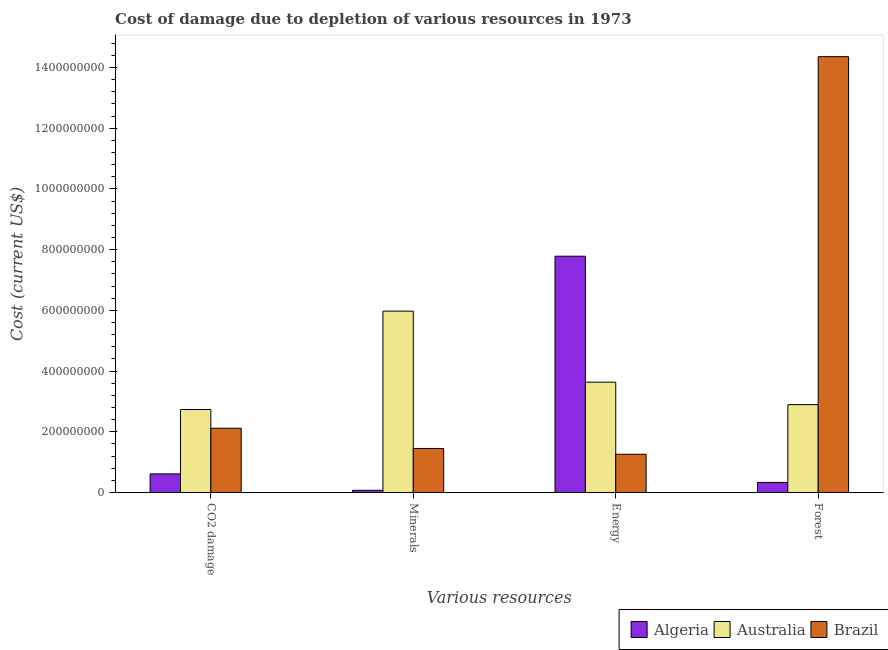Are the number of bars per tick equal to the number of legend labels?
Make the answer very short. Yes. How many bars are there on the 1st tick from the left?
Keep it short and to the point. 3. How many bars are there on the 4th tick from the right?
Make the answer very short. 3. What is the label of the 2nd group of bars from the left?
Your answer should be very brief. Minerals. What is the cost of damage due to depletion of forests in Algeria?
Offer a terse response. 3.31e+07. Across all countries, what is the maximum cost of damage due to depletion of coal?
Your response must be concise. 2.73e+08. Across all countries, what is the minimum cost of damage due to depletion of energy?
Offer a very short reply. 1.26e+08. In which country was the cost of damage due to depletion of coal maximum?
Your response must be concise. Australia. In which country was the cost of damage due to depletion of coal minimum?
Ensure brevity in your answer.  Algeria. What is the total cost of damage due to depletion of minerals in the graph?
Your response must be concise. 7.49e+08. What is the difference between the cost of damage due to depletion of minerals in Australia and that in Algeria?
Offer a very short reply. 5.90e+08. What is the difference between the cost of damage due to depletion of energy in Australia and the cost of damage due to depletion of minerals in Brazil?
Give a very brief answer. 2.18e+08. What is the average cost of damage due to depletion of forests per country?
Offer a terse response. 5.86e+08. What is the difference between the cost of damage due to depletion of coal and cost of damage due to depletion of minerals in Algeria?
Ensure brevity in your answer.  5.41e+07. In how many countries, is the cost of damage due to depletion of forests greater than 120000000 US$?
Offer a very short reply. 2. What is the ratio of the cost of damage due to depletion of energy in Algeria to that in Brazil?
Keep it short and to the point. 6.18. Is the cost of damage due to depletion of minerals in Australia less than that in Algeria?
Ensure brevity in your answer.  No. Is the difference between the cost of damage due to depletion of forests in Australia and Brazil greater than the difference between the cost of damage due to depletion of coal in Australia and Brazil?
Provide a succinct answer. No. What is the difference between the highest and the second highest cost of damage due to depletion of energy?
Your answer should be compact. 4.15e+08. What is the difference between the highest and the lowest cost of damage due to depletion of energy?
Your answer should be compact. 6.52e+08. In how many countries, is the cost of damage due to depletion of forests greater than the average cost of damage due to depletion of forests taken over all countries?
Offer a very short reply. 1. Is it the case that in every country, the sum of the cost of damage due to depletion of coal and cost of damage due to depletion of forests is greater than the sum of cost of damage due to depletion of energy and cost of damage due to depletion of minerals?
Your answer should be compact. No. What does the 3rd bar from the left in CO2 damage represents?
Offer a very short reply. Brazil. Is it the case that in every country, the sum of the cost of damage due to depletion of coal and cost of damage due to depletion of minerals is greater than the cost of damage due to depletion of energy?
Make the answer very short. No. How many bars are there?
Ensure brevity in your answer.  12. Are all the bars in the graph horizontal?
Provide a short and direct response. No. How many countries are there in the graph?
Provide a succinct answer. 3. Does the graph contain grids?
Offer a terse response. No. How many legend labels are there?
Give a very brief answer. 3. How are the legend labels stacked?
Ensure brevity in your answer.  Horizontal. What is the title of the graph?
Your response must be concise. Cost of damage due to depletion of various resources in 1973 . What is the label or title of the X-axis?
Your answer should be very brief. Various resources. What is the label or title of the Y-axis?
Keep it short and to the point. Cost (current US$). What is the Cost (current US$) in Algeria in CO2 damage?
Provide a succinct answer. 6.12e+07. What is the Cost (current US$) in Australia in CO2 damage?
Your answer should be compact. 2.73e+08. What is the Cost (current US$) in Brazil in CO2 damage?
Offer a very short reply. 2.12e+08. What is the Cost (current US$) in Algeria in Minerals?
Your response must be concise. 7.17e+06. What is the Cost (current US$) of Australia in Minerals?
Ensure brevity in your answer.  5.97e+08. What is the Cost (current US$) of Brazil in Minerals?
Your response must be concise. 1.45e+08. What is the Cost (current US$) in Algeria in Energy?
Keep it short and to the point. 7.78e+08. What is the Cost (current US$) in Australia in Energy?
Ensure brevity in your answer.  3.63e+08. What is the Cost (current US$) in Brazil in Energy?
Your response must be concise. 1.26e+08. What is the Cost (current US$) in Algeria in Forest?
Give a very brief answer. 3.31e+07. What is the Cost (current US$) in Australia in Forest?
Give a very brief answer. 2.89e+08. What is the Cost (current US$) in Brazil in Forest?
Your response must be concise. 1.44e+09. Across all Various resources, what is the maximum Cost (current US$) in Algeria?
Offer a terse response. 7.78e+08. Across all Various resources, what is the maximum Cost (current US$) of Australia?
Your answer should be very brief. 5.97e+08. Across all Various resources, what is the maximum Cost (current US$) of Brazil?
Give a very brief answer. 1.44e+09. Across all Various resources, what is the minimum Cost (current US$) in Algeria?
Provide a succinct answer. 7.17e+06. Across all Various resources, what is the minimum Cost (current US$) in Australia?
Offer a terse response. 2.73e+08. Across all Various resources, what is the minimum Cost (current US$) in Brazil?
Offer a terse response. 1.26e+08. What is the total Cost (current US$) of Algeria in the graph?
Make the answer very short. 8.80e+08. What is the total Cost (current US$) in Australia in the graph?
Give a very brief answer. 1.52e+09. What is the total Cost (current US$) of Brazil in the graph?
Your response must be concise. 1.92e+09. What is the difference between the Cost (current US$) of Algeria in CO2 damage and that in Minerals?
Offer a terse response. 5.41e+07. What is the difference between the Cost (current US$) in Australia in CO2 damage and that in Minerals?
Give a very brief answer. -3.24e+08. What is the difference between the Cost (current US$) of Brazil in CO2 damage and that in Minerals?
Provide a short and direct response. 6.67e+07. What is the difference between the Cost (current US$) in Algeria in CO2 damage and that in Energy?
Ensure brevity in your answer.  -7.17e+08. What is the difference between the Cost (current US$) of Australia in CO2 damage and that in Energy?
Offer a terse response. -9.01e+07. What is the difference between the Cost (current US$) of Brazil in CO2 damage and that in Energy?
Make the answer very short. 8.58e+07. What is the difference between the Cost (current US$) of Algeria in CO2 damage and that in Forest?
Offer a terse response. 2.82e+07. What is the difference between the Cost (current US$) of Australia in CO2 damage and that in Forest?
Offer a very short reply. -1.61e+07. What is the difference between the Cost (current US$) in Brazil in CO2 damage and that in Forest?
Your response must be concise. -1.22e+09. What is the difference between the Cost (current US$) of Algeria in Minerals and that in Energy?
Ensure brevity in your answer.  -7.71e+08. What is the difference between the Cost (current US$) in Australia in Minerals and that in Energy?
Provide a short and direct response. 2.34e+08. What is the difference between the Cost (current US$) of Brazil in Minerals and that in Energy?
Keep it short and to the point. 1.90e+07. What is the difference between the Cost (current US$) of Algeria in Minerals and that in Forest?
Give a very brief answer. -2.59e+07. What is the difference between the Cost (current US$) in Australia in Minerals and that in Forest?
Ensure brevity in your answer.  3.08e+08. What is the difference between the Cost (current US$) of Brazil in Minerals and that in Forest?
Keep it short and to the point. -1.29e+09. What is the difference between the Cost (current US$) in Algeria in Energy and that in Forest?
Give a very brief answer. 7.45e+08. What is the difference between the Cost (current US$) in Australia in Energy and that in Forest?
Offer a terse response. 7.41e+07. What is the difference between the Cost (current US$) in Brazil in Energy and that in Forest?
Your answer should be very brief. -1.31e+09. What is the difference between the Cost (current US$) of Algeria in CO2 damage and the Cost (current US$) of Australia in Minerals?
Offer a terse response. -5.36e+08. What is the difference between the Cost (current US$) in Algeria in CO2 damage and the Cost (current US$) in Brazil in Minerals?
Keep it short and to the point. -8.37e+07. What is the difference between the Cost (current US$) in Australia in CO2 damage and the Cost (current US$) in Brazil in Minerals?
Make the answer very short. 1.28e+08. What is the difference between the Cost (current US$) of Algeria in CO2 damage and the Cost (current US$) of Australia in Energy?
Provide a short and direct response. -3.02e+08. What is the difference between the Cost (current US$) of Algeria in CO2 damage and the Cost (current US$) of Brazil in Energy?
Give a very brief answer. -6.47e+07. What is the difference between the Cost (current US$) of Australia in CO2 damage and the Cost (current US$) of Brazil in Energy?
Provide a succinct answer. 1.47e+08. What is the difference between the Cost (current US$) of Algeria in CO2 damage and the Cost (current US$) of Australia in Forest?
Your answer should be compact. -2.28e+08. What is the difference between the Cost (current US$) in Algeria in CO2 damage and the Cost (current US$) in Brazil in Forest?
Keep it short and to the point. -1.37e+09. What is the difference between the Cost (current US$) in Australia in CO2 damage and the Cost (current US$) in Brazil in Forest?
Ensure brevity in your answer.  -1.16e+09. What is the difference between the Cost (current US$) of Algeria in Minerals and the Cost (current US$) of Australia in Energy?
Give a very brief answer. -3.56e+08. What is the difference between the Cost (current US$) of Algeria in Minerals and the Cost (current US$) of Brazil in Energy?
Provide a short and direct response. -1.19e+08. What is the difference between the Cost (current US$) of Australia in Minerals and the Cost (current US$) of Brazil in Energy?
Provide a succinct answer. 4.71e+08. What is the difference between the Cost (current US$) in Algeria in Minerals and the Cost (current US$) in Australia in Forest?
Offer a very short reply. -2.82e+08. What is the difference between the Cost (current US$) in Algeria in Minerals and the Cost (current US$) in Brazil in Forest?
Offer a very short reply. -1.43e+09. What is the difference between the Cost (current US$) in Australia in Minerals and the Cost (current US$) in Brazil in Forest?
Give a very brief answer. -8.38e+08. What is the difference between the Cost (current US$) in Algeria in Energy and the Cost (current US$) in Australia in Forest?
Your response must be concise. 4.89e+08. What is the difference between the Cost (current US$) in Algeria in Energy and the Cost (current US$) in Brazil in Forest?
Offer a very short reply. -6.57e+08. What is the difference between the Cost (current US$) in Australia in Energy and the Cost (current US$) in Brazil in Forest?
Your answer should be very brief. -1.07e+09. What is the average Cost (current US$) in Algeria per Various resources?
Provide a succinct answer. 2.20e+08. What is the average Cost (current US$) of Australia per Various resources?
Keep it short and to the point. 3.81e+08. What is the average Cost (current US$) in Brazil per Various resources?
Keep it short and to the point. 4.80e+08. What is the difference between the Cost (current US$) in Algeria and Cost (current US$) in Australia in CO2 damage?
Ensure brevity in your answer.  -2.12e+08. What is the difference between the Cost (current US$) of Algeria and Cost (current US$) of Brazil in CO2 damage?
Provide a short and direct response. -1.50e+08. What is the difference between the Cost (current US$) in Australia and Cost (current US$) in Brazil in CO2 damage?
Provide a short and direct response. 6.16e+07. What is the difference between the Cost (current US$) in Algeria and Cost (current US$) in Australia in Minerals?
Provide a succinct answer. -5.90e+08. What is the difference between the Cost (current US$) in Algeria and Cost (current US$) in Brazil in Minerals?
Offer a very short reply. -1.38e+08. What is the difference between the Cost (current US$) in Australia and Cost (current US$) in Brazil in Minerals?
Keep it short and to the point. 4.52e+08. What is the difference between the Cost (current US$) in Algeria and Cost (current US$) in Australia in Energy?
Provide a short and direct response. 4.15e+08. What is the difference between the Cost (current US$) in Algeria and Cost (current US$) in Brazil in Energy?
Offer a very short reply. 6.52e+08. What is the difference between the Cost (current US$) of Australia and Cost (current US$) of Brazil in Energy?
Your response must be concise. 2.37e+08. What is the difference between the Cost (current US$) in Algeria and Cost (current US$) in Australia in Forest?
Ensure brevity in your answer.  -2.56e+08. What is the difference between the Cost (current US$) of Algeria and Cost (current US$) of Brazil in Forest?
Provide a succinct answer. -1.40e+09. What is the difference between the Cost (current US$) in Australia and Cost (current US$) in Brazil in Forest?
Keep it short and to the point. -1.15e+09. What is the ratio of the Cost (current US$) of Algeria in CO2 damage to that in Minerals?
Your answer should be compact. 8.54. What is the ratio of the Cost (current US$) in Australia in CO2 damage to that in Minerals?
Your answer should be compact. 0.46. What is the ratio of the Cost (current US$) of Brazil in CO2 damage to that in Minerals?
Provide a short and direct response. 1.46. What is the ratio of the Cost (current US$) in Algeria in CO2 damage to that in Energy?
Make the answer very short. 0.08. What is the ratio of the Cost (current US$) of Australia in CO2 damage to that in Energy?
Offer a very short reply. 0.75. What is the ratio of the Cost (current US$) in Brazil in CO2 damage to that in Energy?
Make the answer very short. 1.68. What is the ratio of the Cost (current US$) of Algeria in CO2 damage to that in Forest?
Your answer should be compact. 1.85. What is the ratio of the Cost (current US$) in Australia in CO2 damage to that in Forest?
Offer a terse response. 0.94. What is the ratio of the Cost (current US$) in Brazil in CO2 damage to that in Forest?
Your response must be concise. 0.15. What is the ratio of the Cost (current US$) in Algeria in Minerals to that in Energy?
Provide a short and direct response. 0.01. What is the ratio of the Cost (current US$) of Australia in Minerals to that in Energy?
Offer a terse response. 1.64. What is the ratio of the Cost (current US$) in Brazil in Minerals to that in Energy?
Give a very brief answer. 1.15. What is the ratio of the Cost (current US$) in Algeria in Minerals to that in Forest?
Your response must be concise. 0.22. What is the ratio of the Cost (current US$) of Australia in Minerals to that in Forest?
Ensure brevity in your answer.  2.06. What is the ratio of the Cost (current US$) of Brazil in Minerals to that in Forest?
Provide a short and direct response. 0.1. What is the ratio of the Cost (current US$) of Algeria in Energy to that in Forest?
Offer a terse response. 23.55. What is the ratio of the Cost (current US$) in Australia in Energy to that in Forest?
Give a very brief answer. 1.26. What is the ratio of the Cost (current US$) in Brazil in Energy to that in Forest?
Offer a very short reply. 0.09. What is the difference between the highest and the second highest Cost (current US$) of Algeria?
Offer a terse response. 7.17e+08. What is the difference between the highest and the second highest Cost (current US$) in Australia?
Offer a very short reply. 2.34e+08. What is the difference between the highest and the second highest Cost (current US$) in Brazil?
Ensure brevity in your answer.  1.22e+09. What is the difference between the highest and the lowest Cost (current US$) in Algeria?
Keep it short and to the point. 7.71e+08. What is the difference between the highest and the lowest Cost (current US$) in Australia?
Provide a succinct answer. 3.24e+08. What is the difference between the highest and the lowest Cost (current US$) in Brazil?
Your answer should be very brief. 1.31e+09. 